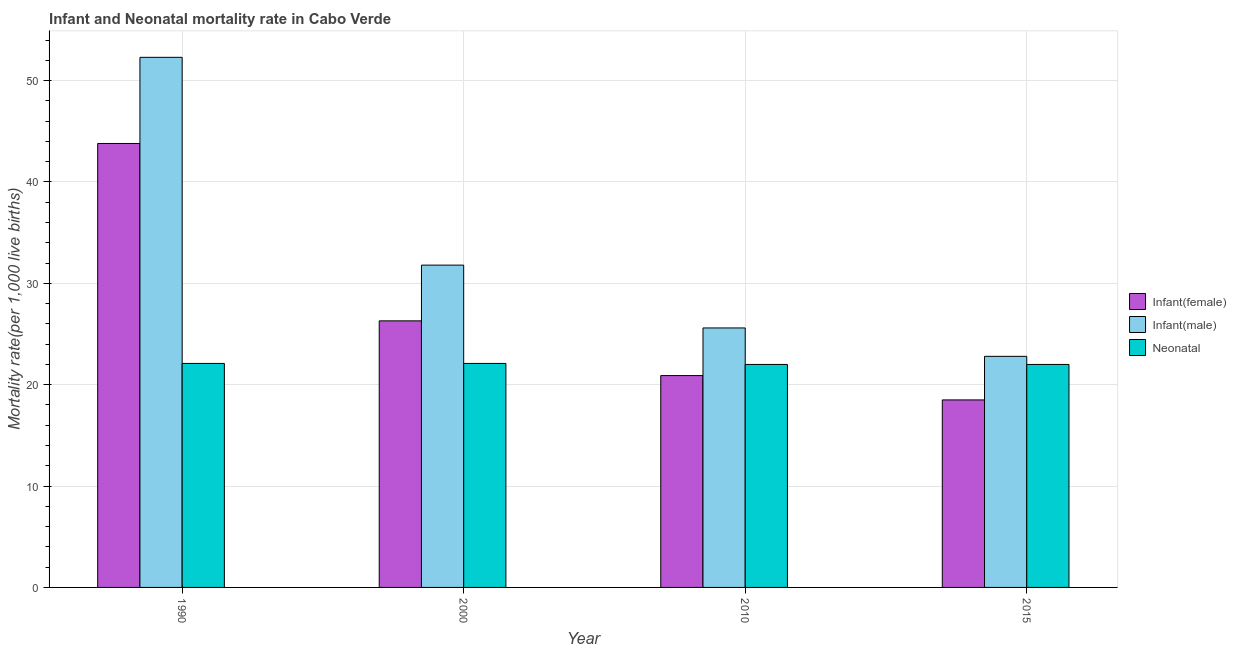How many different coloured bars are there?
Provide a short and direct response. 3. How many groups of bars are there?
Offer a very short reply. 4. Are the number of bars on each tick of the X-axis equal?
Provide a succinct answer. Yes. How many bars are there on the 1st tick from the right?
Keep it short and to the point. 3. What is the label of the 3rd group of bars from the left?
Ensure brevity in your answer.  2010. In how many cases, is the number of bars for a given year not equal to the number of legend labels?
Provide a short and direct response. 0. What is the infant mortality rate(male) in 2015?
Give a very brief answer. 22.8. Across all years, what is the maximum neonatal mortality rate?
Make the answer very short. 22.1. In which year was the infant mortality rate(male) maximum?
Offer a very short reply. 1990. In which year was the infant mortality rate(female) minimum?
Keep it short and to the point. 2015. What is the total infant mortality rate(male) in the graph?
Give a very brief answer. 132.5. What is the difference between the neonatal mortality rate in 2000 and that in 2010?
Offer a terse response. 0.1. What is the difference between the infant mortality rate(female) in 2015 and the neonatal mortality rate in 2010?
Keep it short and to the point. -2.4. What is the average neonatal mortality rate per year?
Offer a terse response. 22.05. In the year 1990, what is the difference between the infant mortality rate(male) and neonatal mortality rate?
Provide a succinct answer. 0. In how many years, is the infant mortality rate(male) greater than 24?
Provide a short and direct response. 3. What is the ratio of the infant mortality rate(male) in 2000 to that in 2010?
Offer a very short reply. 1.24. Is the neonatal mortality rate in 1990 less than that in 2000?
Provide a short and direct response. No. Is the difference between the neonatal mortality rate in 1990 and 2000 greater than the difference between the infant mortality rate(male) in 1990 and 2000?
Ensure brevity in your answer.  No. What is the difference between the highest and the second highest neonatal mortality rate?
Keep it short and to the point. 0. What is the difference between the highest and the lowest infant mortality rate(female)?
Provide a short and direct response. 25.3. In how many years, is the infant mortality rate(female) greater than the average infant mortality rate(female) taken over all years?
Your answer should be very brief. 1. Is the sum of the infant mortality rate(male) in 2010 and 2015 greater than the maximum infant mortality rate(female) across all years?
Provide a succinct answer. No. What does the 2nd bar from the left in 1990 represents?
Give a very brief answer. Infant(male). What does the 2nd bar from the right in 1990 represents?
Provide a short and direct response. Infant(male). Is it the case that in every year, the sum of the infant mortality rate(female) and infant mortality rate(male) is greater than the neonatal mortality rate?
Give a very brief answer. Yes. How many bars are there?
Keep it short and to the point. 12. Are all the bars in the graph horizontal?
Offer a very short reply. No. Does the graph contain grids?
Your answer should be very brief. Yes. Where does the legend appear in the graph?
Provide a short and direct response. Center right. How many legend labels are there?
Give a very brief answer. 3. What is the title of the graph?
Your answer should be compact. Infant and Neonatal mortality rate in Cabo Verde. Does "Textiles and clothing" appear as one of the legend labels in the graph?
Offer a very short reply. No. What is the label or title of the X-axis?
Provide a succinct answer. Year. What is the label or title of the Y-axis?
Offer a very short reply. Mortality rate(per 1,0 live births). What is the Mortality rate(per 1,000 live births) of Infant(female) in 1990?
Offer a very short reply. 43.8. What is the Mortality rate(per 1,000 live births) in Infant(male) in 1990?
Provide a short and direct response. 52.3. What is the Mortality rate(per 1,000 live births) in Neonatal  in 1990?
Provide a short and direct response. 22.1. What is the Mortality rate(per 1,000 live births) in Infant(female) in 2000?
Make the answer very short. 26.3. What is the Mortality rate(per 1,000 live births) of Infant(male) in 2000?
Your answer should be compact. 31.8. What is the Mortality rate(per 1,000 live births) of Neonatal  in 2000?
Your answer should be compact. 22.1. What is the Mortality rate(per 1,000 live births) in Infant(female) in 2010?
Make the answer very short. 20.9. What is the Mortality rate(per 1,000 live births) of Infant(male) in 2010?
Your answer should be very brief. 25.6. What is the Mortality rate(per 1,000 live births) in Neonatal  in 2010?
Provide a succinct answer. 22. What is the Mortality rate(per 1,000 live births) of Infant(female) in 2015?
Provide a short and direct response. 18.5. What is the Mortality rate(per 1,000 live births) of Infant(male) in 2015?
Offer a very short reply. 22.8. What is the Mortality rate(per 1,000 live births) of Neonatal  in 2015?
Ensure brevity in your answer.  22. Across all years, what is the maximum Mortality rate(per 1,000 live births) of Infant(female)?
Your answer should be very brief. 43.8. Across all years, what is the maximum Mortality rate(per 1,000 live births) of Infant(male)?
Provide a succinct answer. 52.3. Across all years, what is the maximum Mortality rate(per 1,000 live births) in Neonatal ?
Provide a succinct answer. 22.1. Across all years, what is the minimum Mortality rate(per 1,000 live births) of Infant(male)?
Your response must be concise. 22.8. What is the total Mortality rate(per 1,000 live births) of Infant(female) in the graph?
Offer a terse response. 109.5. What is the total Mortality rate(per 1,000 live births) in Infant(male) in the graph?
Your answer should be compact. 132.5. What is the total Mortality rate(per 1,000 live births) of Neonatal  in the graph?
Your response must be concise. 88.2. What is the difference between the Mortality rate(per 1,000 live births) in Infant(female) in 1990 and that in 2010?
Your answer should be very brief. 22.9. What is the difference between the Mortality rate(per 1,000 live births) in Infant(male) in 1990 and that in 2010?
Provide a succinct answer. 26.7. What is the difference between the Mortality rate(per 1,000 live births) of Neonatal  in 1990 and that in 2010?
Provide a succinct answer. 0.1. What is the difference between the Mortality rate(per 1,000 live births) in Infant(female) in 1990 and that in 2015?
Ensure brevity in your answer.  25.3. What is the difference between the Mortality rate(per 1,000 live births) in Infant(male) in 1990 and that in 2015?
Your answer should be very brief. 29.5. What is the difference between the Mortality rate(per 1,000 live births) of Neonatal  in 1990 and that in 2015?
Offer a very short reply. 0.1. What is the difference between the Mortality rate(per 1,000 live births) of Infant(female) in 2000 and that in 2010?
Provide a succinct answer. 5.4. What is the difference between the Mortality rate(per 1,000 live births) in Infant(female) in 2000 and that in 2015?
Offer a very short reply. 7.8. What is the difference between the Mortality rate(per 1,000 live births) of Neonatal  in 2000 and that in 2015?
Your answer should be compact. 0.1. What is the difference between the Mortality rate(per 1,000 live births) in Infant(male) in 2010 and that in 2015?
Offer a terse response. 2.8. What is the difference between the Mortality rate(per 1,000 live births) of Neonatal  in 2010 and that in 2015?
Your response must be concise. 0. What is the difference between the Mortality rate(per 1,000 live births) in Infant(female) in 1990 and the Mortality rate(per 1,000 live births) in Infant(male) in 2000?
Ensure brevity in your answer.  12. What is the difference between the Mortality rate(per 1,000 live births) of Infant(female) in 1990 and the Mortality rate(per 1,000 live births) of Neonatal  in 2000?
Offer a very short reply. 21.7. What is the difference between the Mortality rate(per 1,000 live births) of Infant(male) in 1990 and the Mortality rate(per 1,000 live births) of Neonatal  in 2000?
Your answer should be very brief. 30.2. What is the difference between the Mortality rate(per 1,000 live births) of Infant(female) in 1990 and the Mortality rate(per 1,000 live births) of Infant(male) in 2010?
Ensure brevity in your answer.  18.2. What is the difference between the Mortality rate(per 1,000 live births) in Infant(female) in 1990 and the Mortality rate(per 1,000 live births) in Neonatal  in 2010?
Offer a terse response. 21.8. What is the difference between the Mortality rate(per 1,000 live births) of Infant(male) in 1990 and the Mortality rate(per 1,000 live births) of Neonatal  in 2010?
Ensure brevity in your answer.  30.3. What is the difference between the Mortality rate(per 1,000 live births) of Infant(female) in 1990 and the Mortality rate(per 1,000 live births) of Infant(male) in 2015?
Your answer should be very brief. 21. What is the difference between the Mortality rate(per 1,000 live births) of Infant(female) in 1990 and the Mortality rate(per 1,000 live births) of Neonatal  in 2015?
Your response must be concise. 21.8. What is the difference between the Mortality rate(per 1,000 live births) of Infant(male) in 1990 and the Mortality rate(per 1,000 live births) of Neonatal  in 2015?
Your answer should be very brief. 30.3. What is the difference between the Mortality rate(per 1,000 live births) in Infant(female) in 2000 and the Mortality rate(per 1,000 live births) in Neonatal  in 2010?
Offer a terse response. 4.3. What is the difference between the Mortality rate(per 1,000 live births) in Infant(female) in 2000 and the Mortality rate(per 1,000 live births) in Infant(male) in 2015?
Make the answer very short. 3.5. What is the difference between the Mortality rate(per 1,000 live births) of Infant(male) in 2010 and the Mortality rate(per 1,000 live births) of Neonatal  in 2015?
Your answer should be very brief. 3.6. What is the average Mortality rate(per 1,000 live births) of Infant(female) per year?
Provide a short and direct response. 27.38. What is the average Mortality rate(per 1,000 live births) of Infant(male) per year?
Keep it short and to the point. 33.12. What is the average Mortality rate(per 1,000 live births) in Neonatal  per year?
Offer a terse response. 22.05. In the year 1990, what is the difference between the Mortality rate(per 1,000 live births) of Infant(female) and Mortality rate(per 1,000 live births) of Infant(male)?
Keep it short and to the point. -8.5. In the year 1990, what is the difference between the Mortality rate(per 1,000 live births) of Infant(female) and Mortality rate(per 1,000 live births) of Neonatal ?
Your answer should be very brief. 21.7. In the year 1990, what is the difference between the Mortality rate(per 1,000 live births) in Infant(male) and Mortality rate(per 1,000 live births) in Neonatal ?
Your answer should be very brief. 30.2. In the year 2000, what is the difference between the Mortality rate(per 1,000 live births) in Infant(female) and Mortality rate(per 1,000 live births) in Infant(male)?
Give a very brief answer. -5.5. In the year 2000, what is the difference between the Mortality rate(per 1,000 live births) of Infant(female) and Mortality rate(per 1,000 live births) of Neonatal ?
Keep it short and to the point. 4.2. In the year 2000, what is the difference between the Mortality rate(per 1,000 live births) in Infant(male) and Mortality rate(per 1,000 live births) in Neonatal ?
Provide a succinct answer. 9.7. In the year 2010, what is the difference between the Mortality rate(per 1,000 live births) of Infant(female) and Mortality rate(per 1,000 live births) of Neonatal ?
Ensure brevity in your answer.  -1.1. In the year 2015, what is the difference between the Mortality rate(per 1,000 live births) of Infant(female) and Mortality rate(per 1,000 live births) of Neonatal ?
Provide a short and direct response. -3.5. What is the ratio of the Mortality rate(per 1,000 live births) in Infant(female) in 1990 to that in 2000?
Make the answer very short. 1.67. What is the ratio of the Mortality rate(per 1,000 live births) in Infant(male) in 1990 to that in 2000?
Your response must be concise. 1.64. What is the ratio of the Mortality rate(per 1,000 live births) in Neonatal  in 1990 to that in 2000?
Your response must be concise. 1. What is the ratio of the Mortality rate(per 1,000 live births) of Infant(female) in 1990 to that in 2010?
Ensure brevity in your answer.  2.1. What is the ratio of the Mortality rate(per 1,000 live births) in Infant(male) in 1990 to that in 2010?
Give a very brief answer. 2.04. What is the ratio of the Mortality rate(per 1,000 live births) in Neonatal  in 1990 to that in 2010?
Offer a terse response. 1. What is the ratio of the Mortality rate(per 1,000 live births) in Infant(female) in 1990 to that in 2015?
Your response must be concise. 2.37. What is the ratio of the Mortality rate(per 1,000 live births) of Infant(male) in 1990 to that in 2015?
Keep it short and to the point. 2.29. What is the ratio of the Mortality rate(per 1,000 live births) in Infant(female) in 2000 to that in 2010?
Provide a succinct answer. 1.26. What is the ratio of the Mortality rate(per 1,000 live births) of Infant(male) in 2000 to that in 2010?
Your answer should be compact. 1.24. What is the ratio of the Mortality rate(per 1,000 live births) in Neonatal  in 2000 to that in 2010?
Your answer should be very brief. 1. What is the ratio of the Mortality rate(per 1,000 live births) in Infant(female) in 2000 to that in 2015?
Ensure brevity in your answer.  1.42. What is the ratio of the Mortality rate(per 1,000 live births) in Infant(male) in 2000 to that in 2015?
Ensure brevity in your answer.  1.39. What is the ratio of the Mortality rate(per 1,000 live births) of Neonatal  in 2000 to that in 2015?
Offer a very short reply. 1. What is the ratio of the Mortality rate(per 1,000 live births) in Infant(female) in 2010 to that in 2015?
Offer a very short reply. 1.13. What is the ratio of the Mortality rate(per 1,000 live births) of Infant(male) in 2010 to that in 2015?
Offer a very short reply. 1.12. What is the difference between the highest and the second highest Mortality rate(per 1,000 live births) of Neonatal ?
Provide a short and direct response. 0. What is the difference between the highest and the lowest Mortality rate(per 1,000 live births) of Infant(female)?
Keep it short and to the point. 25.3. What is the difference between the highest and the lowest Mortality rate(per 1,000 live births) of Infant(male)?
Make the answer very short. 29.5. What is the difference between the highest and the lowest Mortality rate(per 1,000 live births) of Neonatal ?
Give a very brief answer. 0.1. 